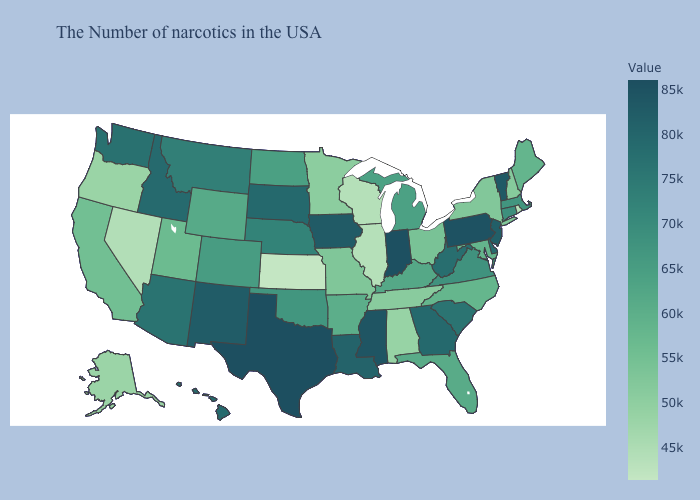Which states have the lowest value in the West?
Write a very short answer. Nevada. Does Montana have a higher value than New Jersey?
Short answer required. No. Does Illinois have a higher value than Nebraska?
Concise answer only. No. Does Florida have the highest value in the South?
Keep it brief. No. Which states hav the highest value in the Northeast?
Short answer required. Pennsylvania. Which states hav the highest value in the South?
Keep it brief. Texas. Is the legend a continuous bar?
Short answer required. Yes. 